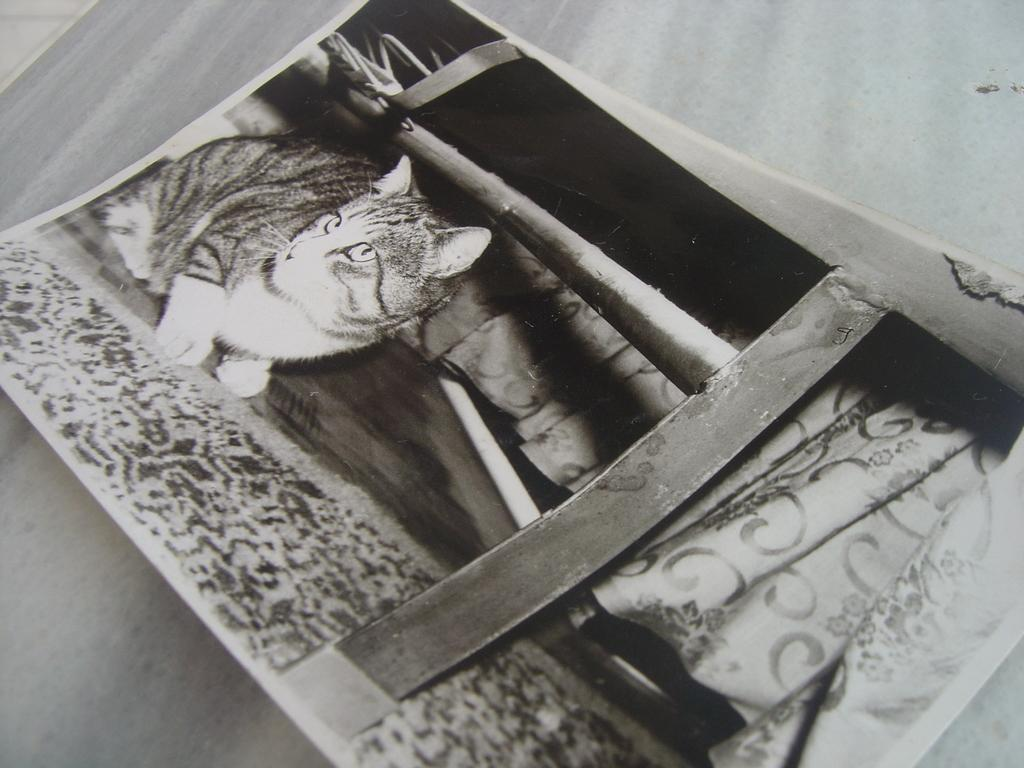What is the color scheme of the image? The image is black and white. What is the main subject of the image? There is a photograph on a wooden surface in the image. What can be seen in the photograph? There is a cat in the photograph, as well as a table and a curtain. What is the plot of the story being told by the cat in the photograph? There is no story being told by the cat in the photograph, as it is a still image and not a narrative. 